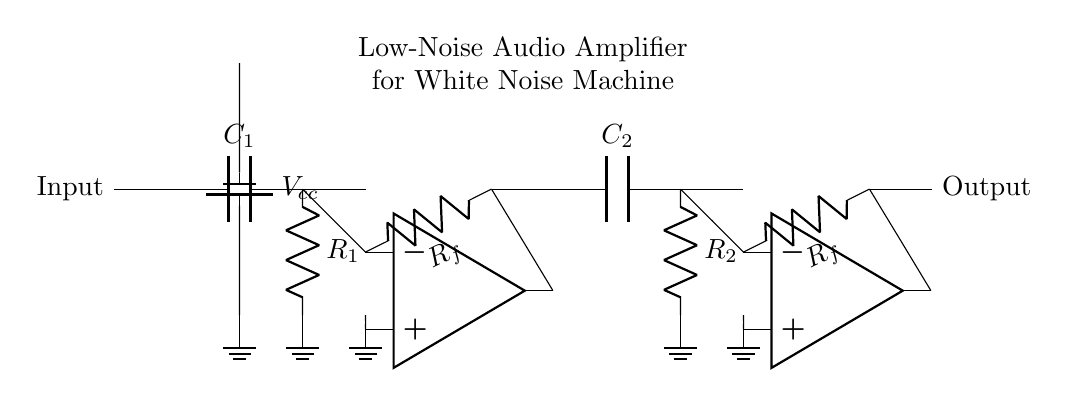What type of circuit is depicted? The circuit is an audio amplifier, specifically a low-noise audio amplifier intended for white noise machines to mask external disturbances. This is indicated by the labels and the overall design of the circuit.
Answer: audio amplifier What is the input component in the circuit? The input component in the circuit is a capacitor labeled **C1**. It is positioned at the beginning of the circuit diagram and is followed by a resistor, suggestive of a filtering or coupling function.
Answer: C1 How many operational amplifiers are used? There are two operational amplifiers in the circuit. Each is represented by a triangle symbol labeled as **op amp** and appears in distinct stages of the amplification process.
Answer: 2 What type of feedback is used in the amplifiers? The feedback used in both stages of the amplifier is resistive feedback, indicated by the resistors labeled **Rf** connecting the output of the operational amplifiers back to their inverting inputs. This design is characteristic of non-inverting amplifier configurations.
Answer: resistive What is the purpose of the coupling capacitors? The purpose of the coupling capacitors, **C1** and **C2**, is to block DC voltage while allowing AC signals to pass through. This is crucial for maintaining signal integrity, particularly in audio applications, by isolating different stages of the amplifier.
Answer: to block DC voltage What is the expected function of this circuit? The expected function of this circuit is to amplify low-level audio signals, such as white noise from a white noise machine, to a greater amplitude to effectively mask external disturbances like loud noises from a nightclub.
Answer: amplify audio signals 